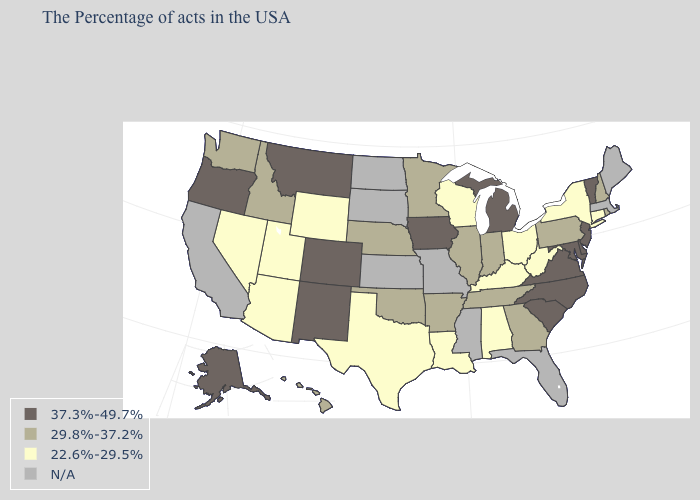Name the states that have a value in the range N/A?
Short answer required. Maine, Massachusetts, Florida, Mississippi, Missouri, Kansas, South Dakota, North Dakota, California. Does the first symbol in the legend represent the smallest category?
Concise answer only. No. What is the value of Tennessee?
Give a very brief answer. 29.8%-37.2%. Does the first symbol in the legend represent the smallest category?
Write a very short answer. No. Is the legend a continuous bar?
Give a very brief answer. No. Name the states that have a value in the range 22.6%-29.5%?
Quick response, please. Connecticut, New York, West Virginia, Ohio, Kentucky, Alabama, Wisconsin, Louisiana, Texas, Wyoming, Utah, Arizona, Nevada. Name the states that have a value in the range 22.6%-29.5%?
Quick response, please. Connecticut, New York, West Virginia, Ohio, Kentucky, Alabama, Wisconsin, Louisiana, Texas, Wyoming, Utah, Arizona, Nevada. Does Michigan have the highest value in the MidWest?
Give a very brief answer. Yes. What is the value of Rhode Island?
Answer briefly. 29.8%-37.2%. Which states have the lowest value in the Northeast?
Write a very short answer. Connecticut, New York. Name the states that have a value in the range 37.3%-49.7%?
Give a very brief answer. Vermont, New Jersey, Delaware, Maryland, Virginia, North Carolina, South Carolina, Michigan, Iowa, Colorado, New Mexico, Montana, Oregon, Alaska. Among the states that border West Virginia , does Kentucky have the lowest value?
Answer briefly. Yes. Among the states that border Oregon , does Nevada have the highest value?
Quick response, please. No. What is the value of South Carolina?
Answer briefly. 37.3%-49.7%. 